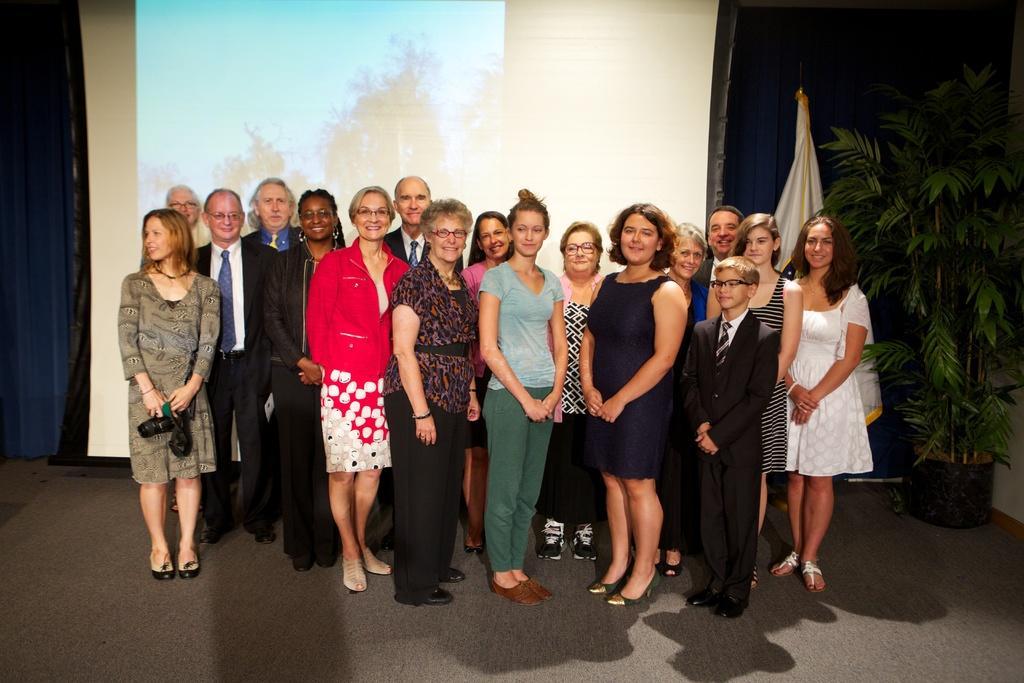Please provide a concise description of this image. In this image I can see a group of people standing and wearing different color dresses. Back I can see a flower pot,blue curtain and projector screen. 